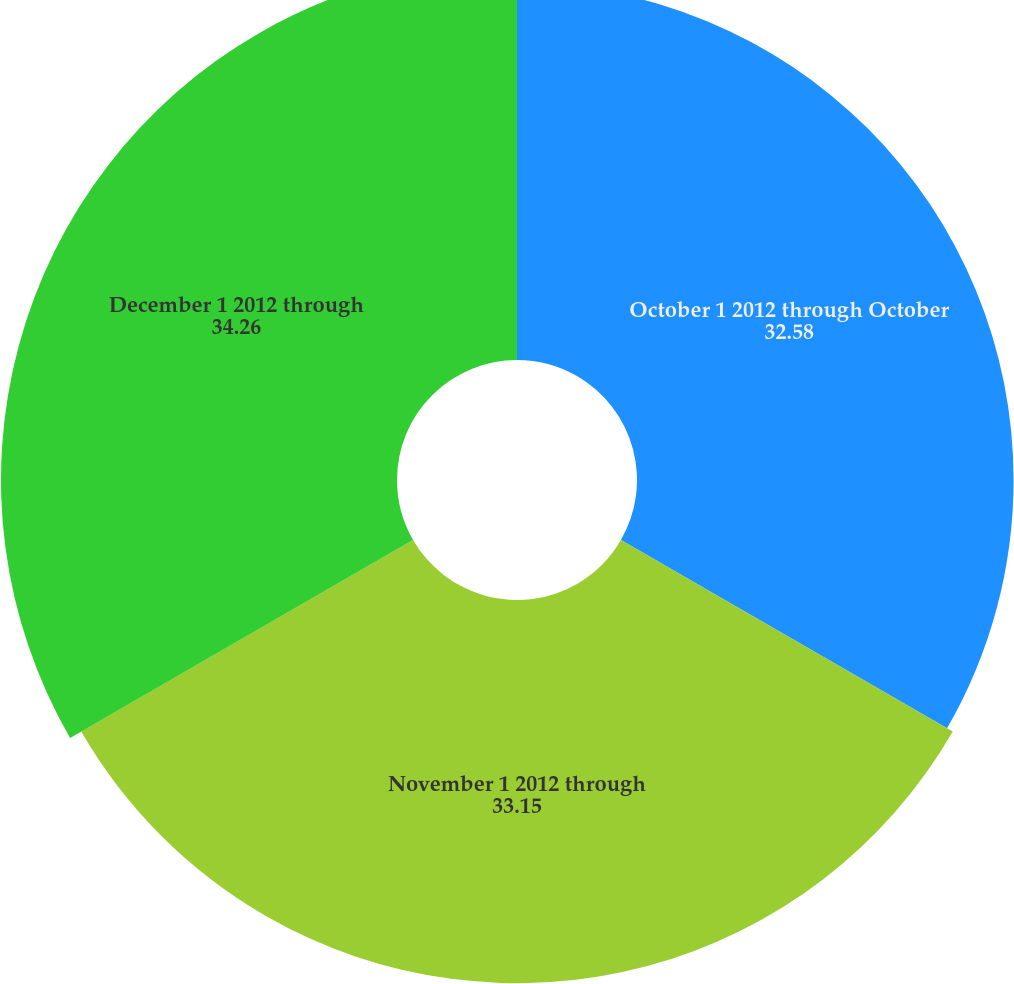Convert chart. <chart><loc_0><loc_0><loc_500><loc_500><pie_chart><fcel>October 1 2012 through October<fcel>November 1 2012 through<fcel>December 1 2012 through<nl><fcel>32.58%<fcel>33.15%<fcel>34.26%<nl></chart> 